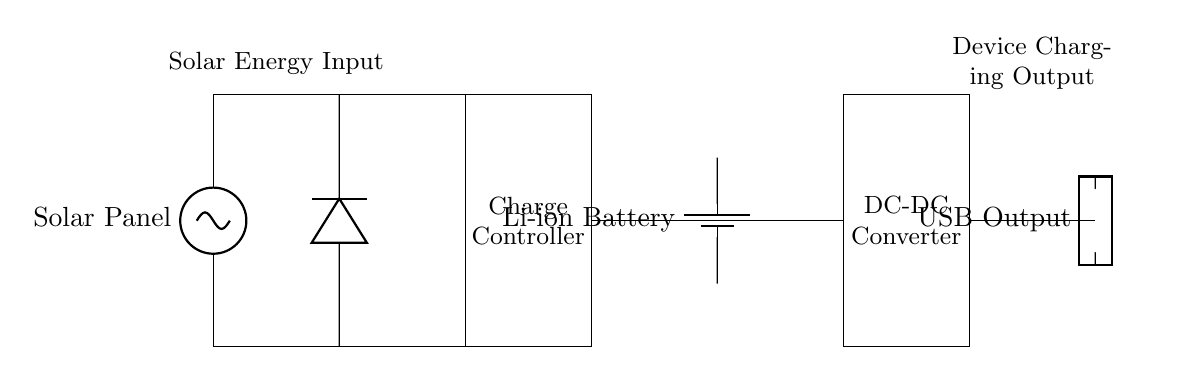What is the primary power source for this circuit? The primary power source is the solar panel, which converts solar energy into electrical energy. This is identified in the circuit diagram at the leftmost position as the component labeled "Solar Panel."
Answer: Solar Panel What type of battery is used in this circuit? The circuit uses a Li-ion battery as indicated by the label on the battery component in the diagram. Li-ion batteries are commonly used for portable applications due to their high energy density and rechargeability.
Answer: Li-ion Battery What component regulates the charging of the battery? The component that regulates the charging of the battery is the charge controller, which is explicitly marked in the diagram. It ensures the battery is charged properly and prevents overcharging.
Answer: Charge Controller How many components directly connect to the battery? There are two components that directly connect to the battery: the charge controller and the DC-DC converter. The charge controller is connected to the positive and negative terminals of the battery, and the DC-DC converter also connects to the battery in the circuit.
Answer: Two What is the output type of this circuit for charging devices? The circuit has a USB output for charging devices, which is indicated by the labeled output component on the right side of the diagram. USB outputs are standard for charging many electronic devices.
Answer: USB Output What is the purpose of the DC-DC converter in this circuit? The purpose of the DC-DC converter is to adjust the voltage levels coming from the battery to match the voltage requirements of the devices being charged. This is essential for ensuring compatibility and safe charging of various devices.
Answer: Adjust voltage 